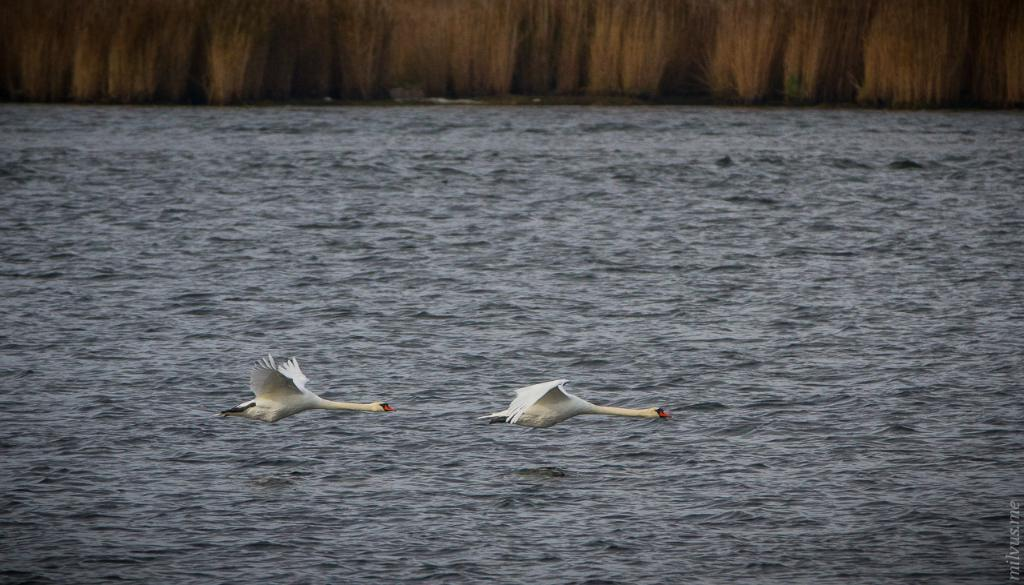What is happening in the sky in the image? There are birds flying in the sky. What can be seen in the background of the image? There is water and plants visible in the background. What type of cake is being served on the curved cord in the image? There is no cake or curved cord present in the image; it features birds flying in the sky and water with plants in the background. 